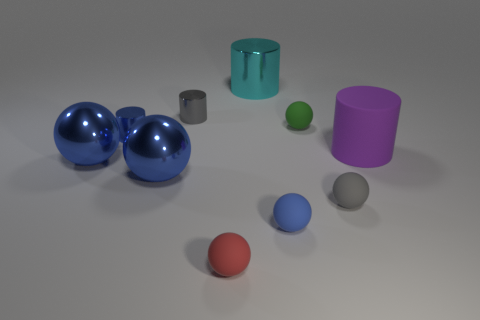The blue metallic thing that is the same shape as the purple thing is what size?
Your answer should be compact. Small. Are there more small gray matte spheres that are to the right of the large purple rubber object than tiny green objects that are to the left of the red sphere?
Your answer should be compact. No. What material is the cylinder that is to the left of the green matte sphere and in front of the green matte object?
Ensure brevity in your answer.  Metal. There is another matte thing that is the same shape as the large cyan object; what color is it?
Your response must be concise. Purple. What is the size of the green ball?
Your response must be concise. Small. There is a metallic cylinder right of the gray thing that is left of the small green sphere; what is its color?
Provide a succinct answer. Cyan. How many metallic things are both on the left side of the small red ball and behind the large rubber object?
Your answer should be very brief. 2. Are there more cyan shiny things than small cylinders?
Ensure brevity in your answer.  No. What is the large purple cylinder made of?
Provide a succinct answer. Rubber. What number of tiny blue metallic objects are behind the matte ball that is left of the blue rubber thing?
Ensure brevity in your answer.  1. 